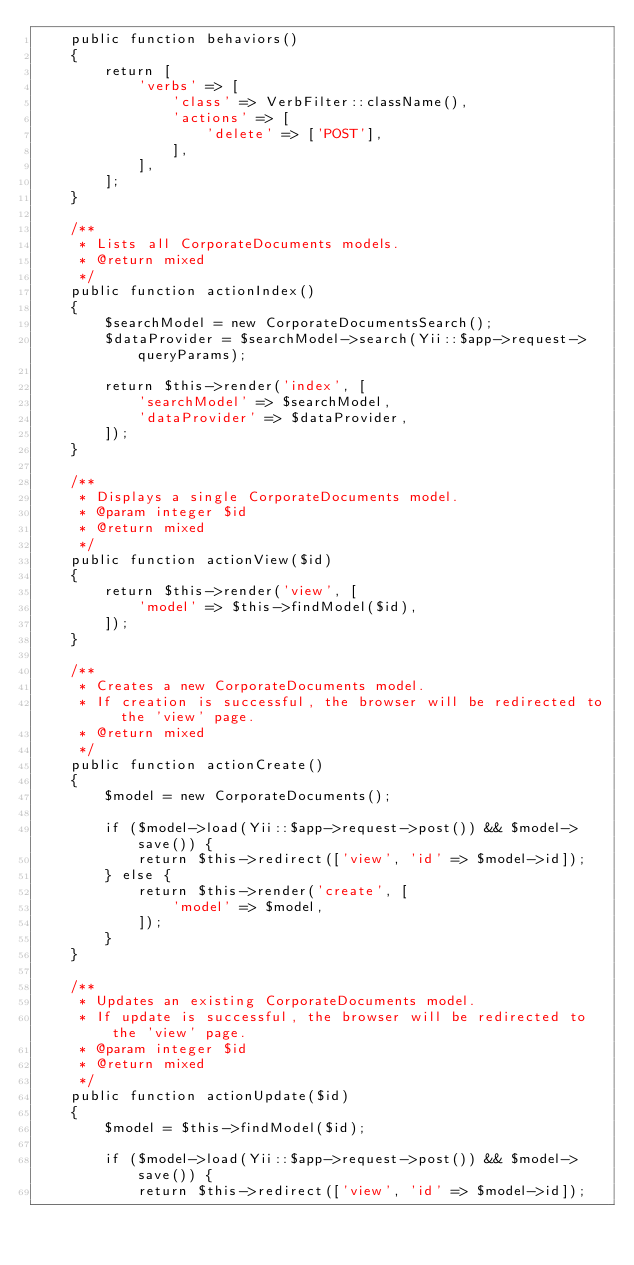Convert code to text. <code><loc_0><loc_0><loc_500><loc_500><_PHP_>    public function behaviors()
    {
        return [
            'verbs' => [
                'class' => VerbFilter::className(),
                'actions' => [
                    'delete' => ['POST'],
                ],
            ],
        ];
    }

    /**
     * Lists all CorporateDocuments models.
     * @return mixed
     */
    public function actionIndex()
    {
        $searchModel = new CorporateDocumentsSearch();
        $dataProvider = $searchModel->search(Yii::$app->request->queryParams);

        return $this->render('index', [
            'searchModel' => $searchModel,
            'dataProvider' => $dataProvider,
        ]);
    }

    /**
     * Displays a single CorporateDocuments model.
     * @param integer $id
     * @return mixed
     */
    public function actionView($id)
    {
        return $this->render('view', [
            'model' => $this->findModel($id),
        ]);
    }

    /**
     * Creates a new CorporateDocuments model.
     * If creation is successful, the browser will be redirected to the 'view' page.
     * @return mixed
     */
    public function actionCreate()
    {
        $model = new CorporateDocuments();

        if ($model->load(Yii::$app->request->post()) && $model->save()) {
            return $this->redirect(['view', 'id' => $model->id]);
        } else {
            return $this->render('create', [
                'model' => $model,
            ]);
        }
    }

    /**
     * Updates an existing CorporateDocuments model.
     * If update is successful, the browser will be redirected to the 'view' page.
     * @param integer $id
     * @return mixed
     */
    public function actionUpdate($id)
    {
        $model = $this->findModel($id);

        if ($model->load(Yii::$app->request->post()) && $model->save()) {
            return $this->redirect(['view', 'id' => $model->id]);</code> 